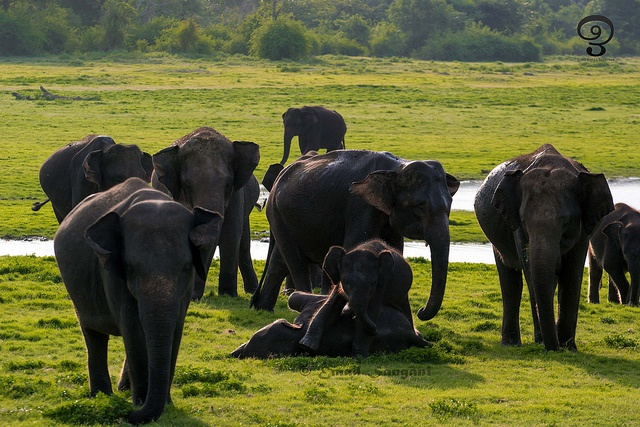Describe the objects in this image and their specific colors. I can see elephant in gray, black, darkgreen, and olive tones, elephant in gray and black tones, elephant in gray, black, olive, and darkgreen tones, elephant in gray and black tones, and elephant in gray, black, and maroon tones in this image. 